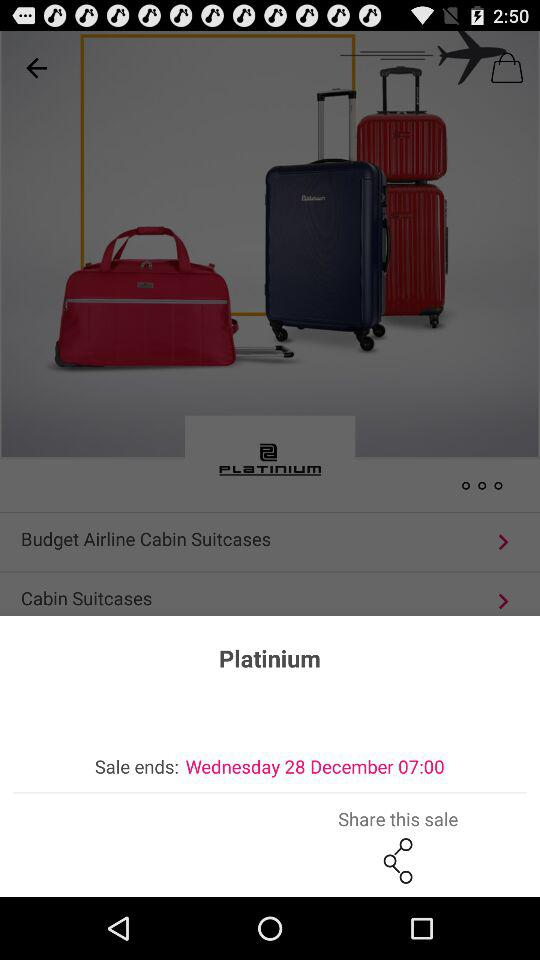What is the end date of the sale? The end date of the sale is December 28, Wednesday. 